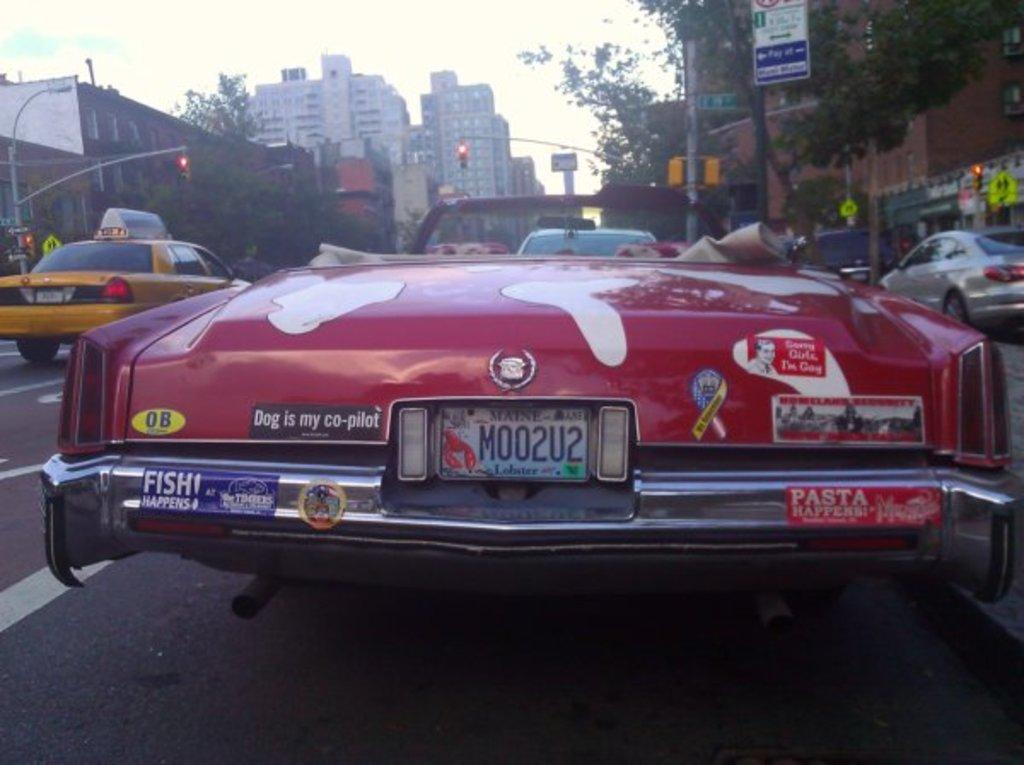<image>
Share a concise interpretation of the image provided. A bruised and battered old car has a bumper sticker on it reading "Dog is my co-pilot". 